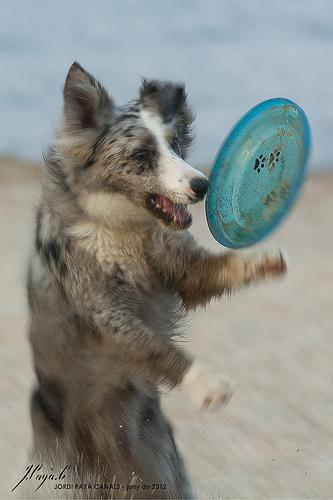How would you describe the weather and environment in the image? It is a sunny daytime beach scene with clear bright sunny blue sky. Identify the primary activity taking place in the image. A dog is jumping to catch a blue frisbee in the air on a beach. Mention an additional detail on the frisbee aside from the paw prints. There is wet sand on the front of the blue frisbee. What kind of information is written on the photograph? There is black copy wright information indicating the photographer. What is the color of the dog's eye, nose, and tongue? The dog has an amber eye with a black pupil, a black nose, and a pink tongue. What kind of prints are on the frisbee and what color are they? There are black paw prints on the blue frisbee. Analyze the interaction between the dog and the frisbee in the image. The dog is in mid-air, jumping and aiming to bite the blue frisbee with its open mouth and teeth. What is the breed of the dog and what is it trying to do? The dog is an Australian Shepherd and it is trying to catch a blue frisbee in the air. Count the number of black paw prints visible on the frisbee. There are two black paw print images on the frisbee. Describe the physical features of the dog, such as its colors and markings. The dog has gray and black fur, a white snout, and black spots on its head. Can you locate the purple kite flying in the sky? I'm sorry, but there is no purple kite visible in the image. Can you see the multiple beach umbrellas partially covering the view of the ocean? There are no beach umbrellas visible in the image. Identify the green seaweed scattered along the shoreline. There is no green seaweed visible along the shoreline in the image. Observe the three-legged cat sitting at the edge of the water. There is no three-legged cat in the image. Notice how the little girl in a sun hat claps her hands as the dog jumps. There is no little girl in a sun hat visible in the image. Please observe the hot air balloon floating above the water in the distance. There is no hot air balloon visible in the image. 